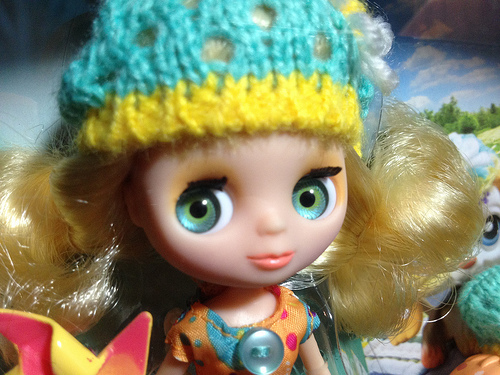<image>
Can you confirm if the button is under the wig? No. The button is not positioned under the wig. The vertical relationship between these objects is different. 